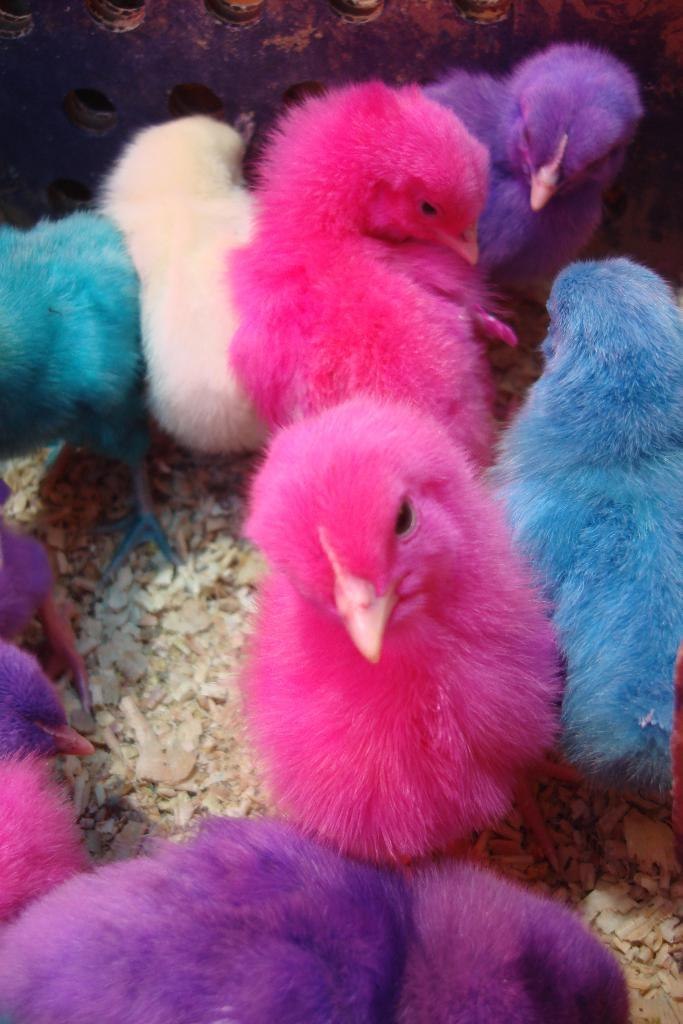What type of animals are in the image? There are chickens in the image. Can you describe the appearance of the chickens? The chickens have different colors. Where are the chickens located in the image? The chickens are in the middle of the image. What type of cup is being used to weigh the chickens in the image? There is no cup or scale present in the image, and the chickens are not being weighed. 